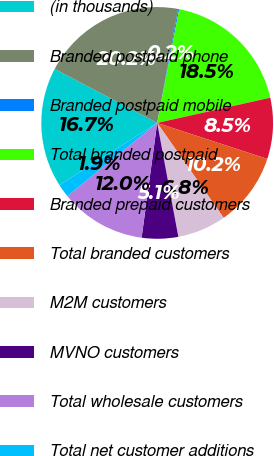Convert chart to OTSL. <chart><loc_0><loc_0><loc_500><loc_500><pie_chart><fcel>(in thousands)<fcel>Branded postpaid phone<fcel>Branded postpaid mobile<fcel>Total branded postpaid<fcel>Branded prepaid customers<fcel>Total branded customers<fcel>M2M customers<fcel>MVNO customers<fcel>Total wholesale customers<fcel>Total net customer additions<nl><fcel>16.73%<fcel>20.18%<fcel>0.15%<fcel>18.46%<fcel>8.52%<fcel>10.25%<fcel>6.8%<fcel>5.07%<fcel>11.97%<fcel>1.87%<nl></chart> 